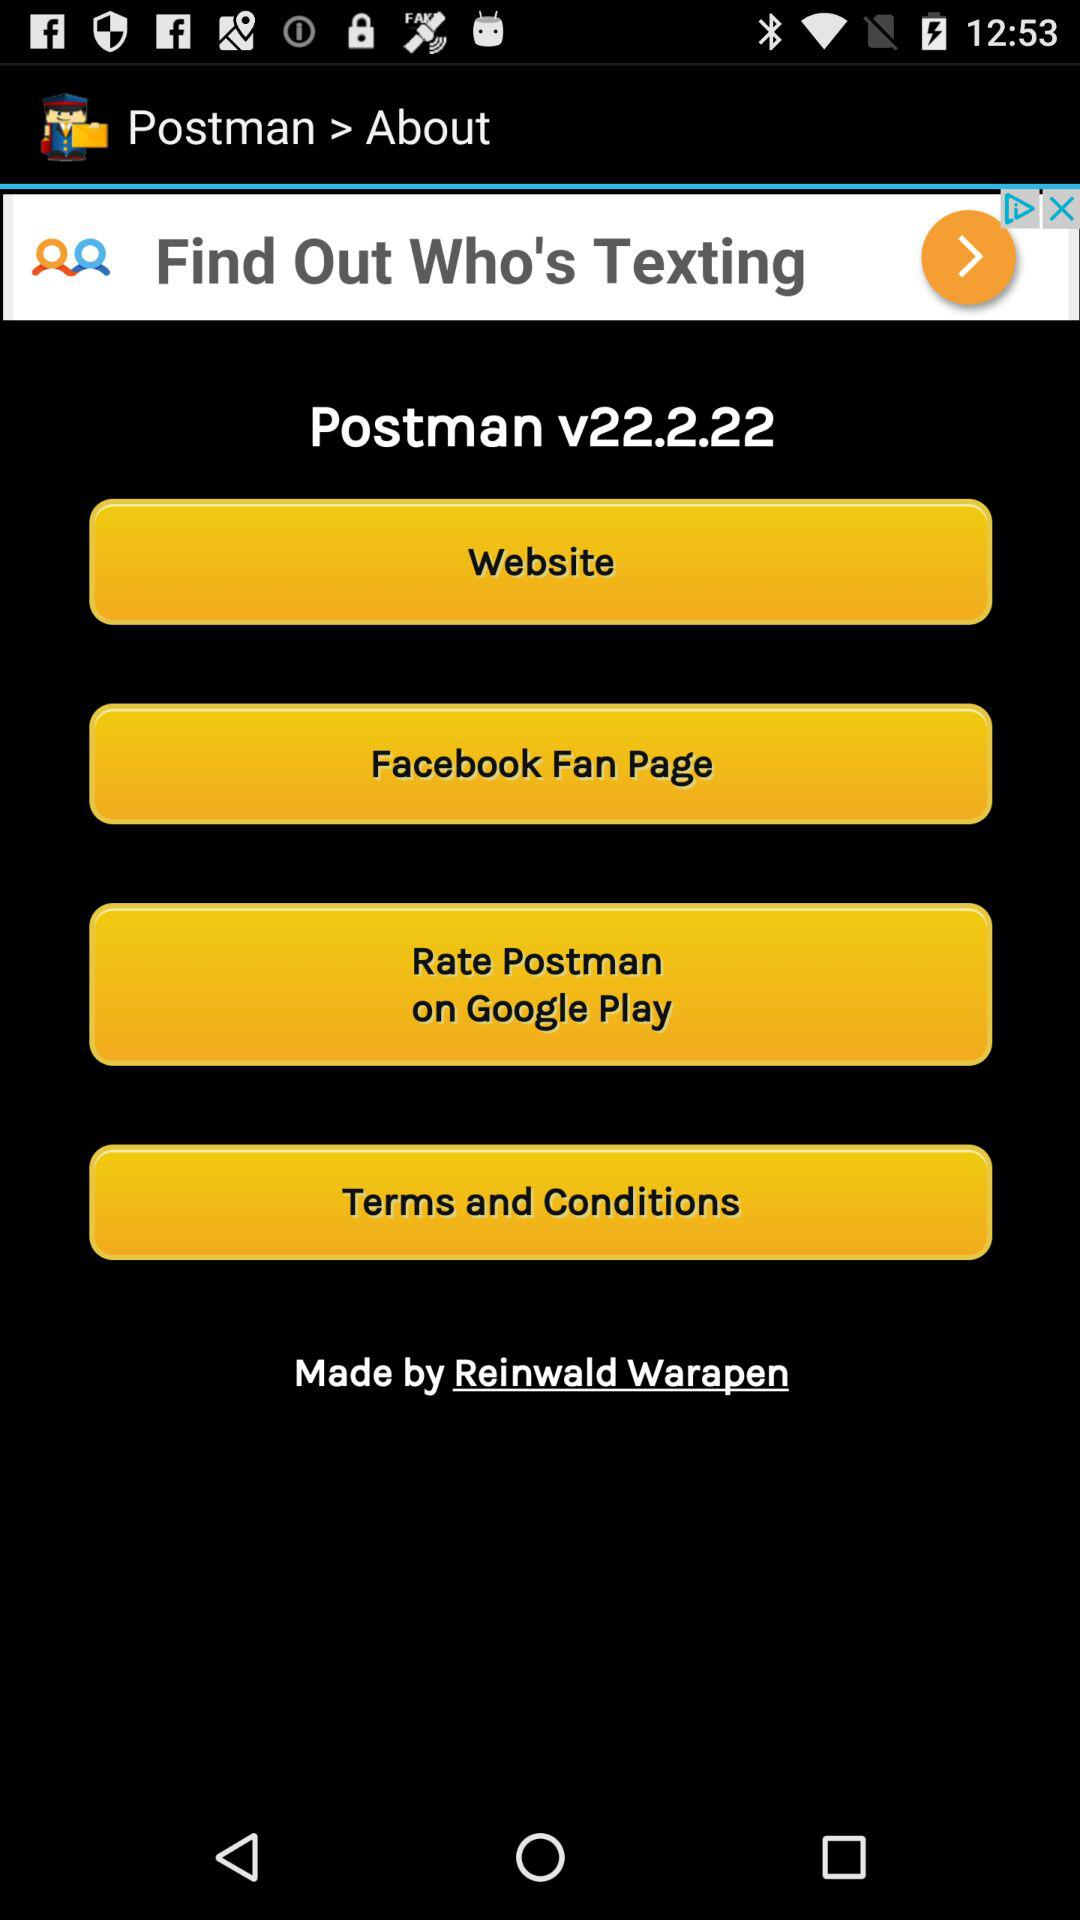What is the name of the application? The name of the application is "Postman". 